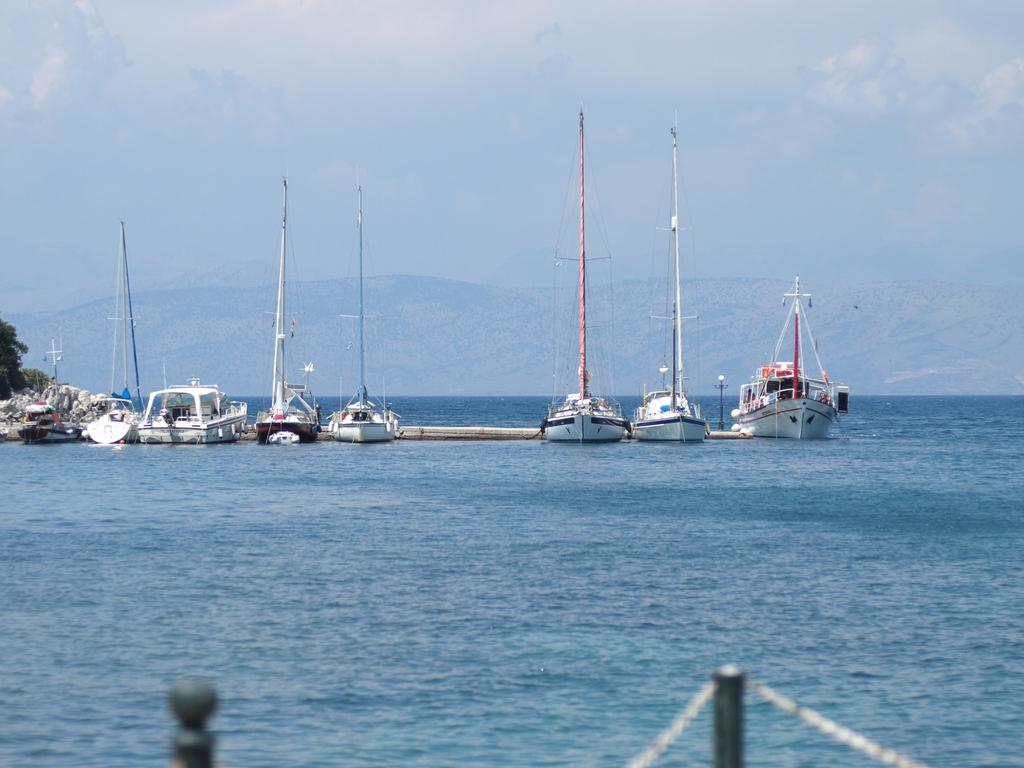What is on the water in the image? There are ships on the water in the image. What type of vegetation can be seen in the image? There are trees in the image. What geographical feature is present in the image? There is a mountain in the image. What is visible in the background of the image? The sky is visible in the background of the image. Who is the creator of the mountain in the image? The mountain is a natural geographical feature and does not have a creator. Can you see any elbows in the image? There are no elbows present in the image. 